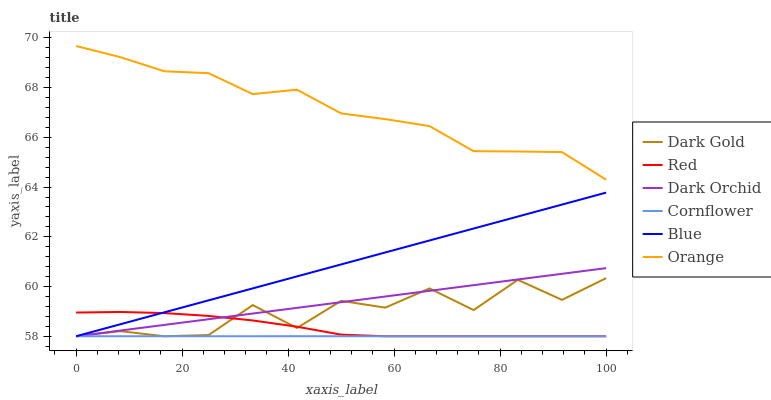Does Cornflower have the minimum area under the curve?
Answer yes or no. Yes. Does Orange have the maximum area under the curve?
Answer yes or no. Yes. Does Dark Gold have the minimum area under the curve?
Answer yes or no. No. Does Dark Gold have the maximum area under the curve?
Answer yes or no. No. Is Blue the smoothest?
Answer yes or no. Yes. Is Dark Gold the roughest?
Answer yes or no. Yes. Is Cornflower the smoothest?
Answer yes or no. No. Is Cornflower the roughest?
Answer yes or no. No. Does Blue have the lowest value?
Answer yes or no. Yes. Does Orange have the lowest value?
Answer yes or no. No. Does Orange have the highest value?
Answer yes or no. Yes. Does Dark Gold have the highest value?
Answer yes or no. No. Is Cornflower less than Orange?
Answer yes or no. Yes. Is Orange greater than Blue?
Answer yes or no. Yes. Does Red intersect Dark Gold?
Answer yes or no. Yes. Is Red less than Dark Gold?
Answer yes or no. No. Is Red greater than Dark Gold?
Answer yes or no. No. Does Cornflower intersect Orange?
Answer yes or no. No. 